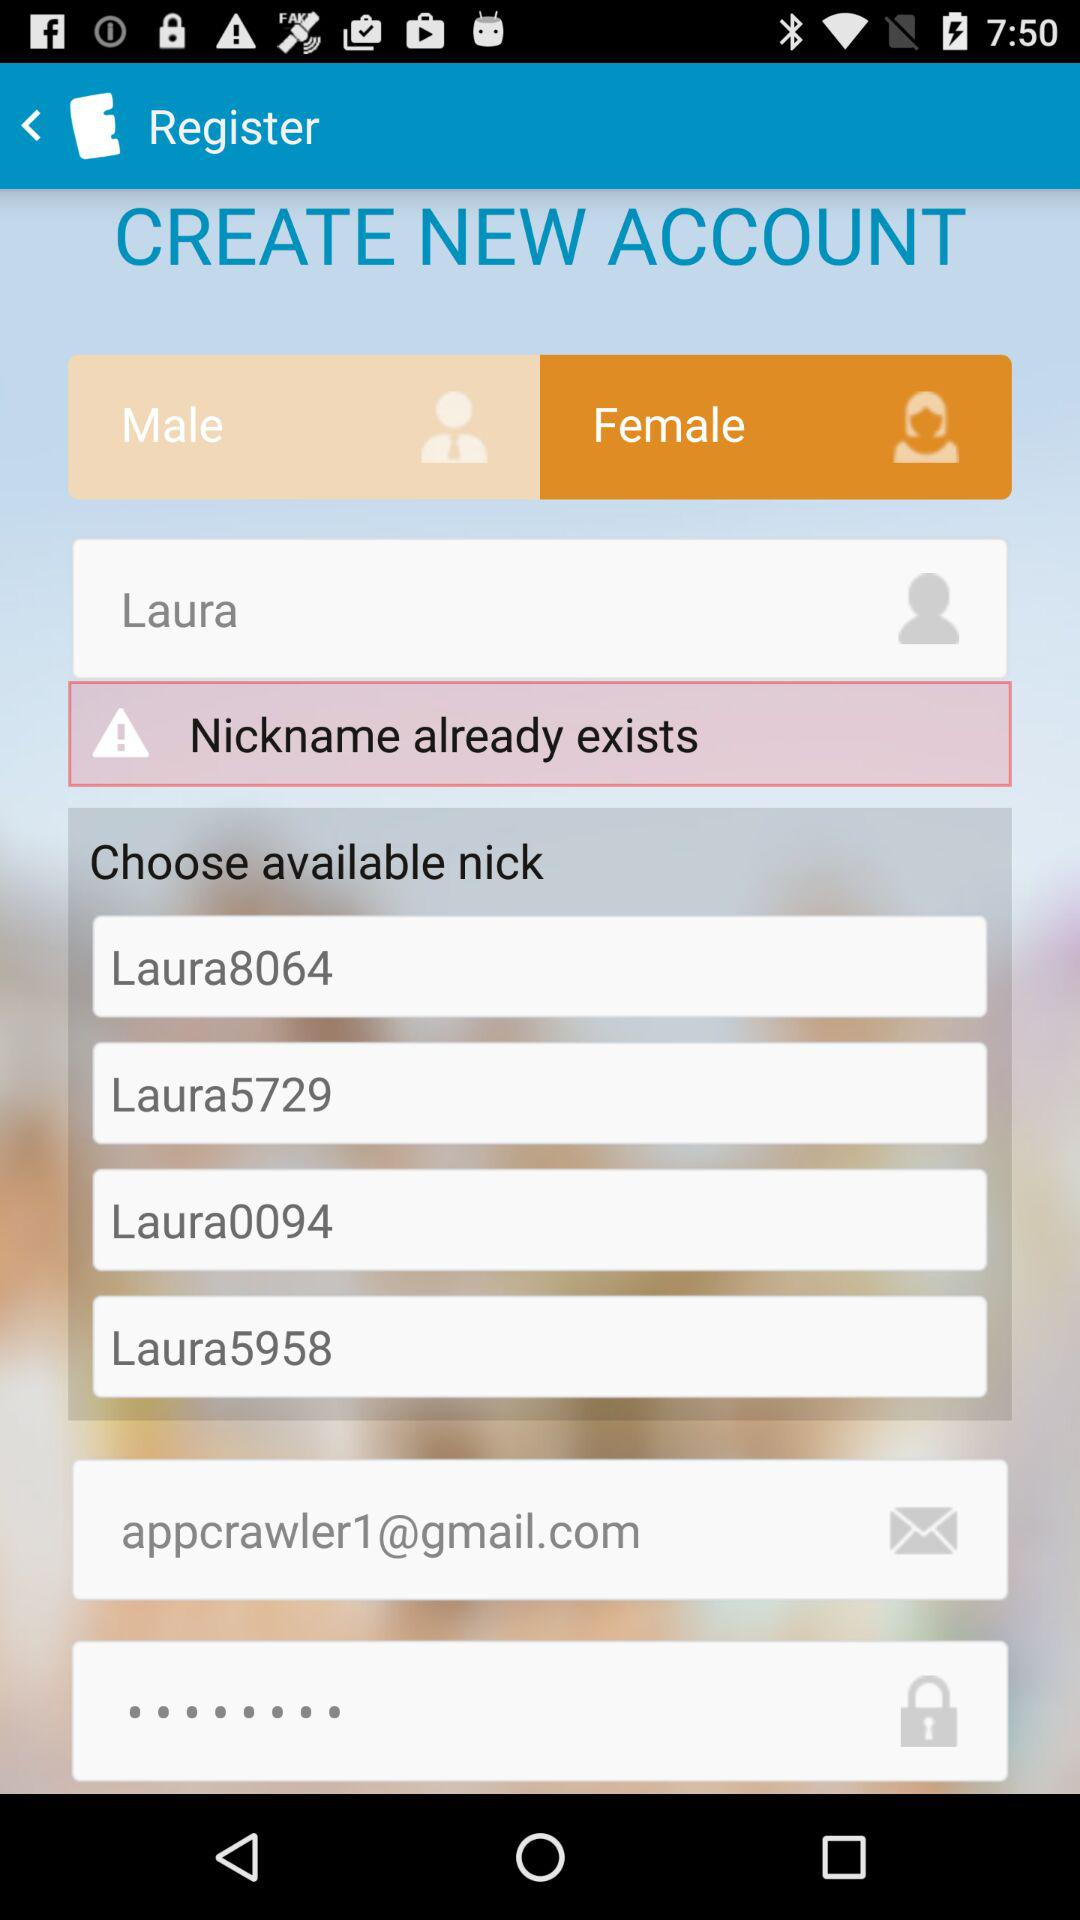What is the nickname? The nickname is Laura. 